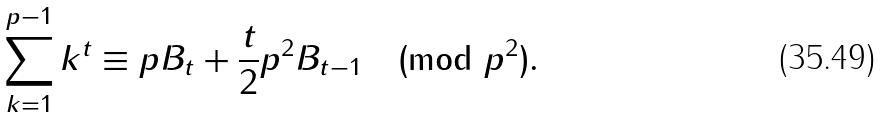<formula> <loc_0><loc_0><loc_500><loc_500>\sum _ { k = 1 } ^ { p - 1 } k ^ { t } \equiv p B _ { t } + \frac { t } { 2 } p ^ { 2 } B _ { t - 1 } \pmod { p ^ { 2 } } .</formula> 